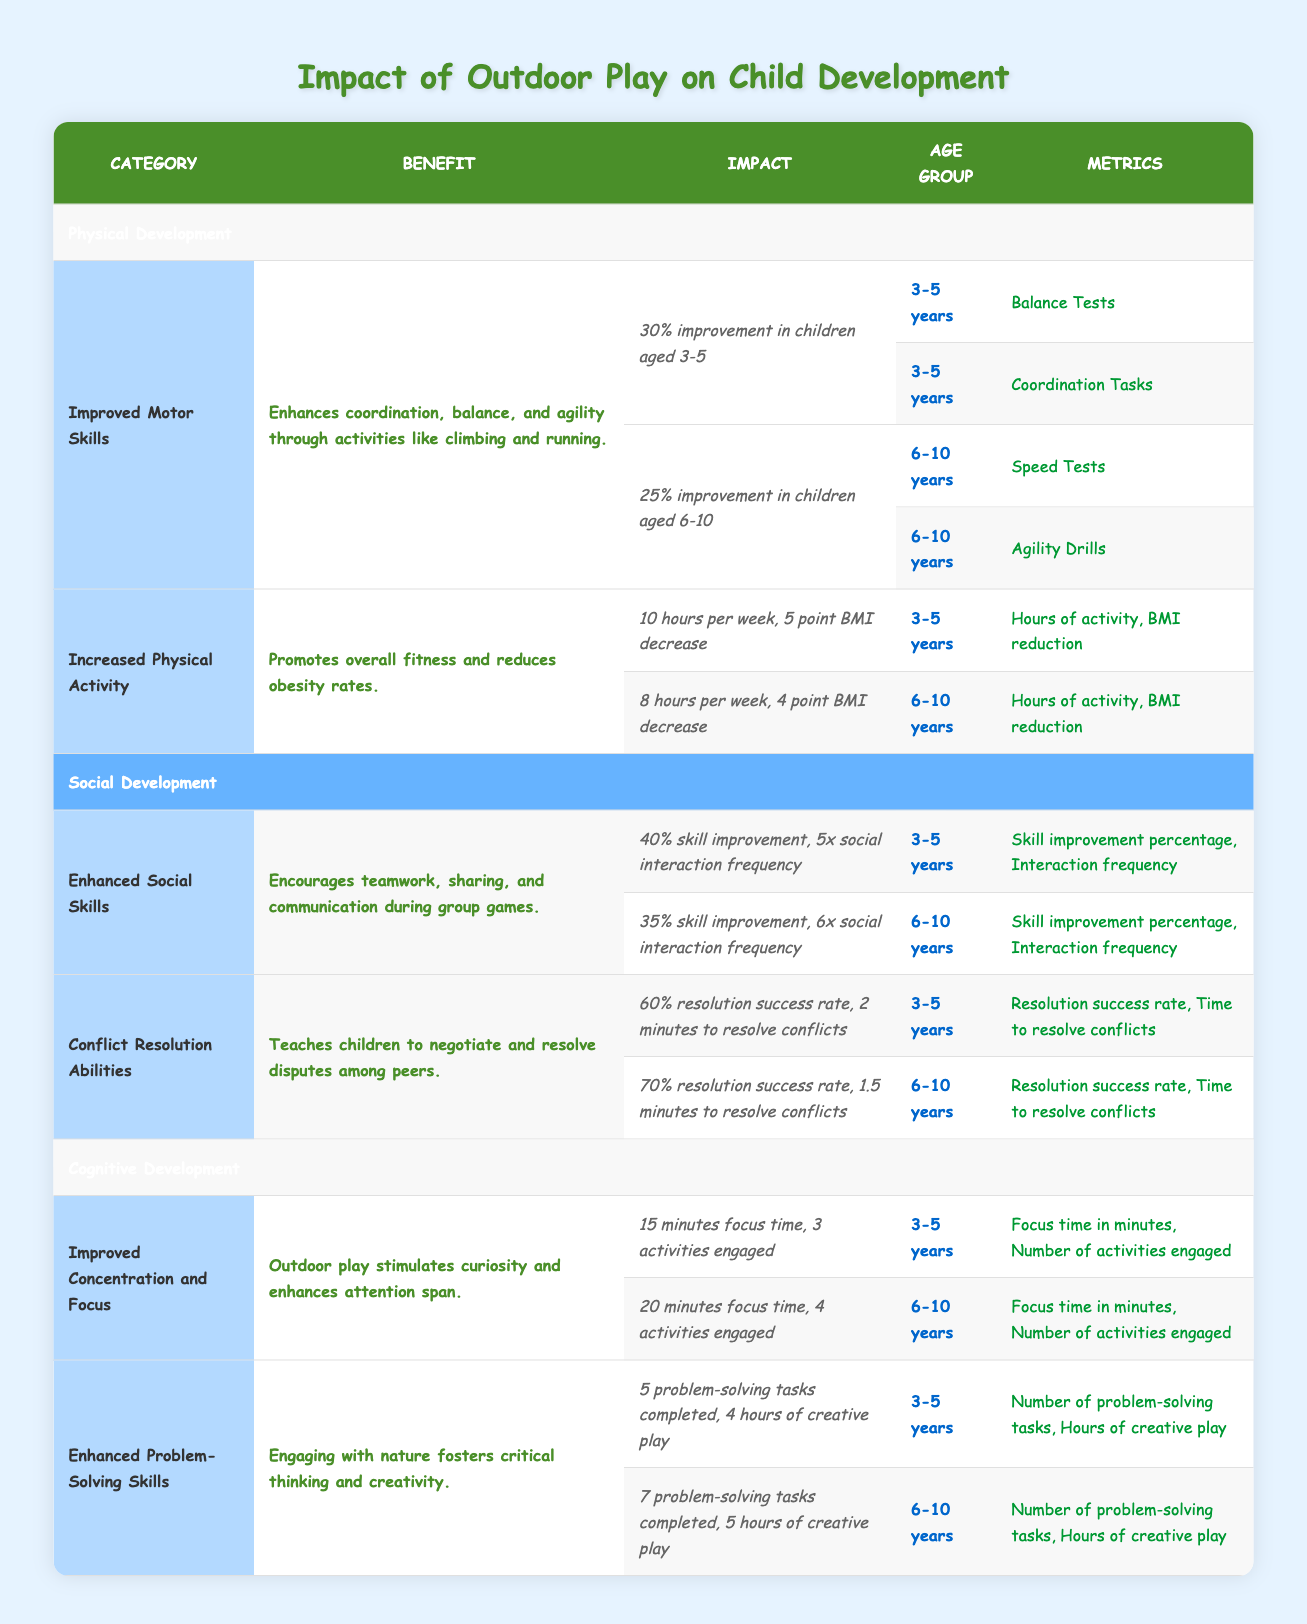What percentage of improvement in motor skills is observed in children aged 3 to 5? From the table, it is clearly stated that there is a 30% improvement in motor skills for children aged 3 to 5.
Answer: 30% What are the metrics used to measure increased physical activity in children aged 6 to 10? According to the table, the metrics for increased physical activity in children aged 6 to 10 are "Hours of activity" and "BMI reduction."
Answer: Hours of activity, BMI reduction Is there evidence in the table that outdoor play enhances social skills in children aged 6 to 10? Yes, the table shows that there is a 35% skill improvement and an interaction frequency of 6 for children aged 6 to 10, indicating that outdoor play enhances social skills.
Answer: Yes How does the hours of physical activity and BMI decrease compare between ages 3 to 5 and 6 to 10? For ages 3 to 5, children engage in 10 hours of physical activity and experience a 5 point decrease in BMI. In comparison, children aged 6 to 10 engage in 8 hours of activity with a 4 point decrease in BMI. This shows that younger children are more active and experience a greater reduction in BMI.
Answer: Younger children are more active and have a greater BMI reduction What is the average focus time in minutes for children aged 3 to 10? In the table, for children aged 3 to 5, the focus time is 15 minutes. For children aged 6 to 10, the focus time is 20 minutes. The average is calculated as (15 + 20)/2 = 17.5 minutes.
Answer: 17.5 minutes What is the resolution success rate for conflict resolution abilities in children aged 3 to 5? The table indicates that the resolution success rate for children aged 3 to 5 is 60%.
Answer: 60% Is it true that outdoor play improves problem-solving skills for both age groups? Yes, the table shows that both age groups, 3 to 5 and 6 to 10, show improvements in problem-solving tasks completed, with 5 tasks completed for the younger group and 7 for the older group, indicating that outdoor play improves problem-solving skills.
Answer: Yes If a child aged 6 to 10 completes 7 problem-solving tasks, what was the number completed by a child aged 3 to 5? The table states that for children aged 3 to 5, 5 problem-solving tasks are completed.
Answer: 5 tasks 